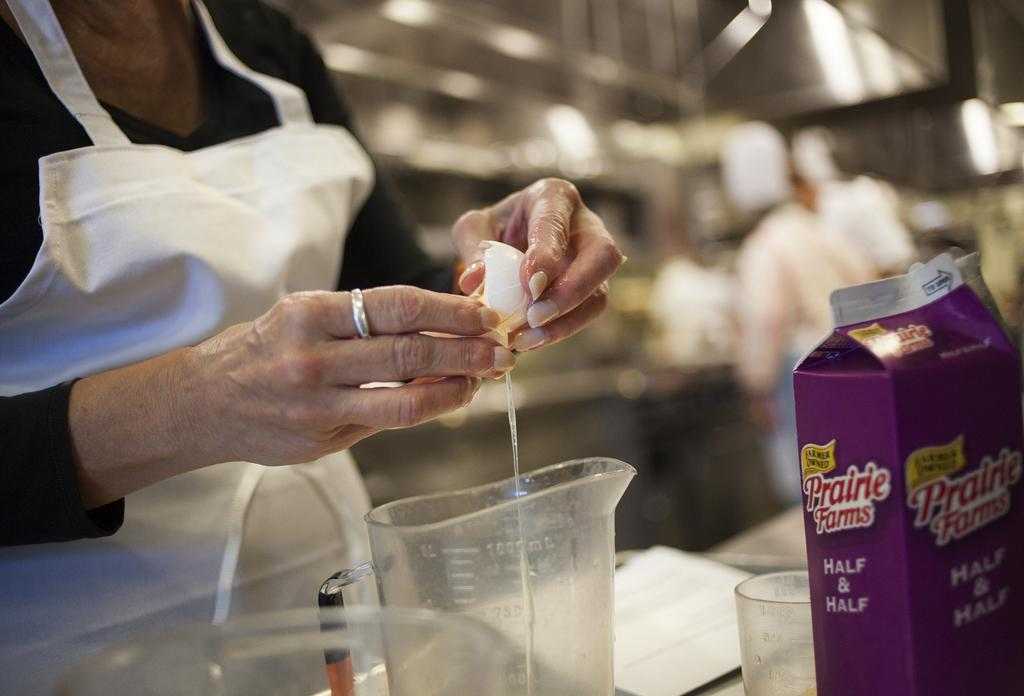<image>
Present a compact description of the photo's key features. A person cracking an egg into a container with a carton of Prairie Farms half and half nearby. 